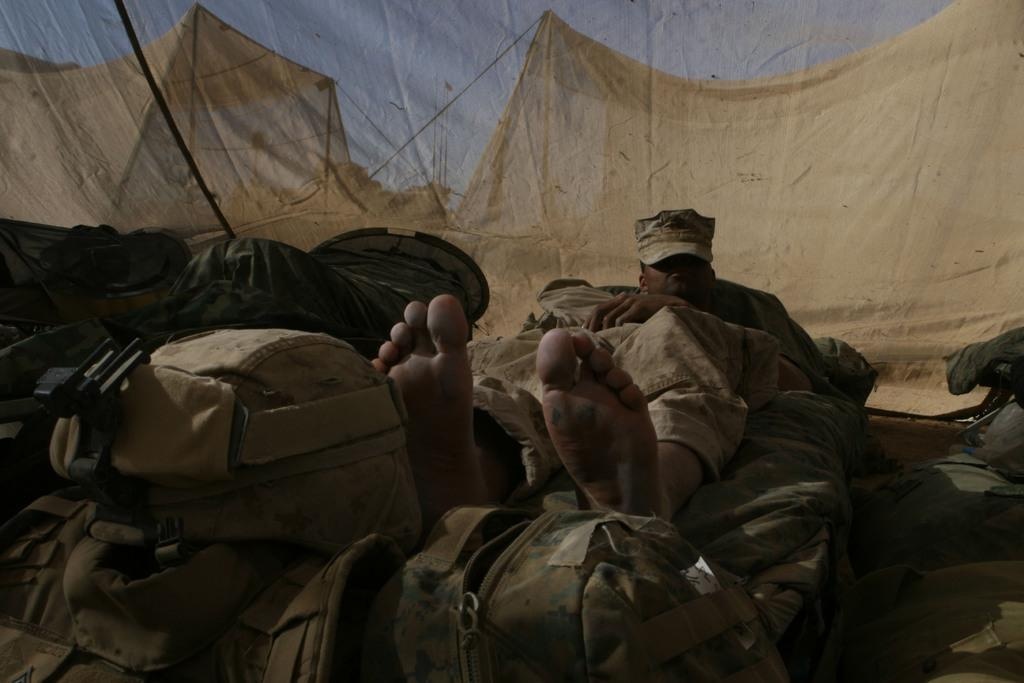Who is present in the image? There is a man in the image. What objects are located at the bottom of the image? There are bags at the bottom of the image. What type of structures can be seen in the background of the image? There are tents in the background of the image. What is visible at the top of the image? The sky is visible at the top of the image. What type of trail does the man follow in the image? There is no trail visible in the image; it only shows a man, bags, tents, and the sky. 